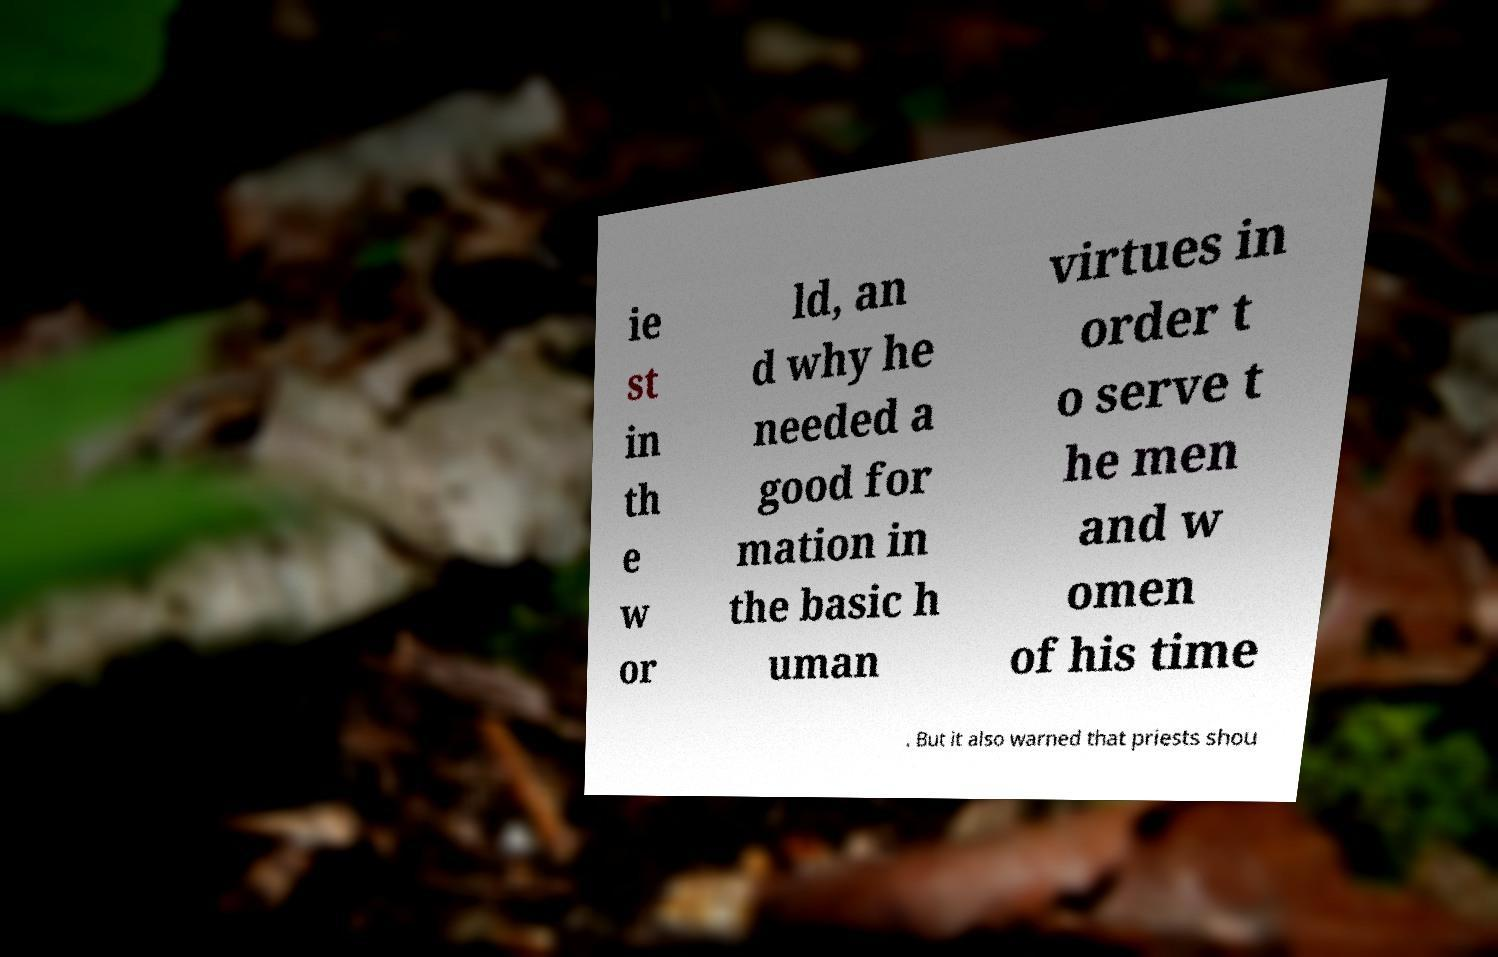What messages or text are displayed in this image? I need them in a readable, typed format. ie st in th e w or ld, an d why he needed a good for mation in the basic h uman virtues in order t o serve t he men and w omen of his time . But it also warned that priests shou 